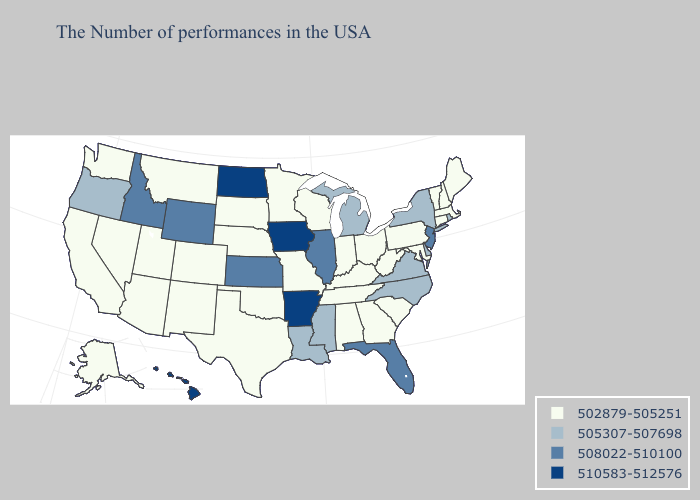Among the states that border New Jersey , does Pennsylvania have the lowest value?
Give a very brief answer. Yes. What is the lowest value in the South?
Answer briefly. 502879-505251. Among the states that border Wisconsin , does Iowa have the highest value?
Keep it brief. Yes. Does the map have missing data?
Write a very short answer. No. Name the states that have a value in the range 502879-505251?
Write a very short answer. Maine, Massachusetts, New Hampshire, Vermont, Connecticut, Maryland, Pennsylvania, South Carolina, West Virginia, Ohio, Georgia, Kentucky, Indiana, Alabama, Tennessee, Wisconsin, Missouri, Minnesota, Nebraska, Oklahoma, Texas, South Dakota, Colorado, New Mexico, Utah, Montana, Arizona, Nevada, California, Washington, Alaska. What is the value of North Carolina?
Short answer required. 505307-507698. What is the value of Oklahoma?
Quick response, please. 502879-505251. Does Pennsylvania have the lowest value in the Northeast?
Concise answer only. Yes. Which states have the lowest value in the USA?
Keep it brief. Maine, Massachusetts, New Hampshire, Vermont, Connecticut, Maryland, Pennsylvania, South Carolina, West Virginia, Ohio, Georgia, Kentucky, Indiana, Alabama, Tennessee, Wisconsin, Missouri, Minnesota, Nebraska, Oklahoma, Texas, South Dakota, Colorado, New Mexico, Utah, Montana, Arizona, Nevada, California, Washington, Alaska. Does Wyoming have the same value as Idaho?
Concise answer only. Yes. Among the states that border New Jersey , which have the lowest value?
Keep it brief. Pennsylvania. Does the map have missing data?
Give a very brief answer. No. Does Connecticut have a lower value than South Carolina?
Be succinct. No. Does Georgia have the highest value in the USA?
Quick response, please. No. Name the states that have a value in the range 510583-512576?
Keep it brief. Arkansas, Iowa, North Dakota, Hawaii. 